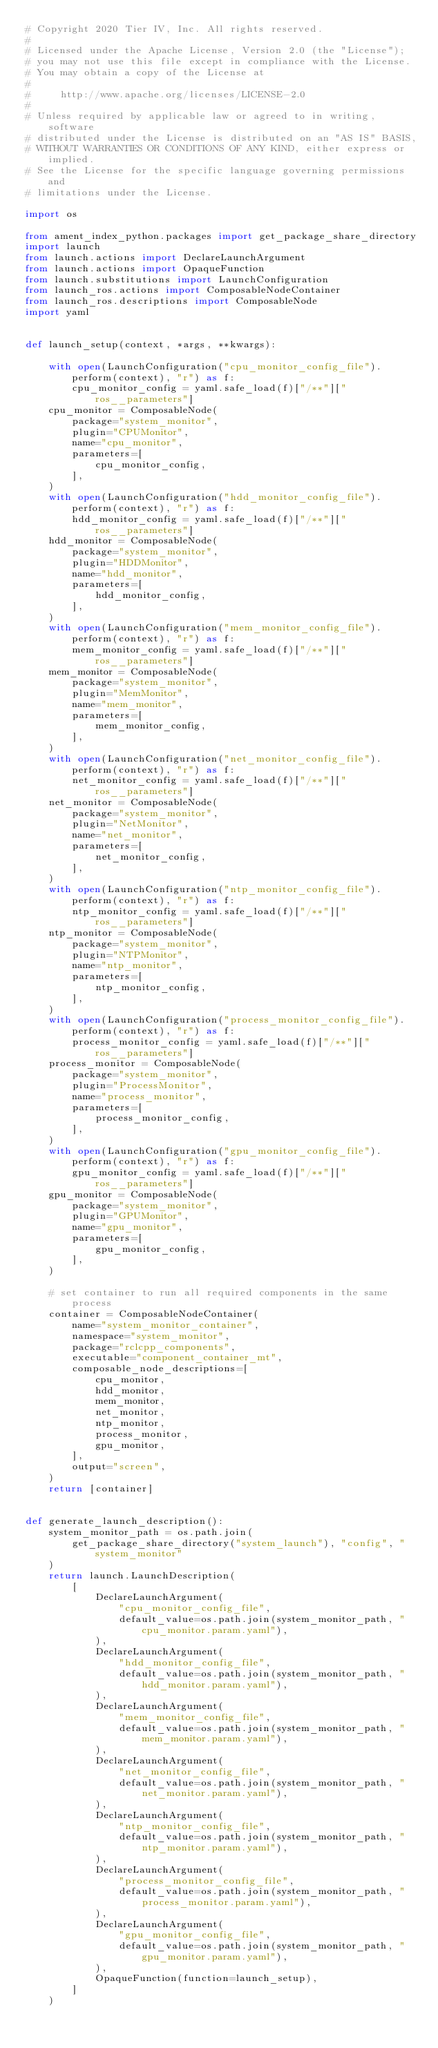Convert code to text. <code><loc_0><loc_0><loc_500><loc_500><_Python_># Copyright 2020 Tier IV, Inc. All rights reserved.
#
# Licensed under the Apache License, Version 2.0 (the "License");
# you may not use this file except in compliance with the License.
# You may obtain a copy of the License at
#
#     http://www.apache.org/licenses/LICENSE-2.0
#
# Unless required by applicable law or agreed to in writing, software
# distributed under the License is distributed on an "AS IS" BASIS,
# WITHOUT WARRANTIES OR CONDITIONS OF ANY KIND, either express or implied.
# See the License for the specific language governing permissions and
# limitations under the License.

import os

from ament_index_python.packages import get_package_share_directory
import launch
from launch.actions import DeclareLaunchArgument
from launch.actions import OpaqueFunction
from launch.substitutions import LaunchConfiguration
from launch_ros.actions import ComposableNodeContainer
from launch_ros.descriptions import ComposableNode
import yaml


def launch_setup(context, *args, **kwargs):

    with open(LaunchConfiguration("cpu_monitor_config_file").perform(context), "r") as f:
        cpu_monitor_config = yaml.safe_load(f)["/**"]["ros__parameters"]
    cpu_monitor = ComposableNode(
        package="system_monitor",
        plugin="CPUMonitor",
        name="cpu_monitor",
        parameters=[
            cpu_monitor_config,
        ],
    )
    with open(LaunchConfiguration("hdd_monitor_config_file").perform(context), "r") as f:
        hdd_monitor_config = yaml.safe_load(f)["/**"]["ros__parameters"]
    hdd_monitor = ComposableNode(
        package="system_monitor",
        plugin="HDDMonitor",
        name="hdd_monitor",
        parameters=[
            hdd_monitor_config,
        ],
    )
    with open(LaunchConfiguration("mem_monitor_config_file").perform(context), "r") as f:
        mem_monitor_config = yaml.safe_load(f)["/**"]["ros__parameters"]
    mem_monitor = ComposableNode(
        package="system_monitor",
        plugin="MemMonitor",
        name="mem_monitor",
        parameters=[
            mem_monitor_config,
        ],
    )
    with open(LaunchConfiguration("net_monitor_config_file").perform(context), "r") as f:
        net_monitor_config = yaml.safe_load(f)["/**"]["ros__parameters"]
    net_monitor = ComposableNode(
        package="system_monitor",
        plugin="NetMonitor",
        name="net_monitor",
        parameters=[
            net_monitor_config,
        ],
    )
    with open(LaunchConfiguration("ntp_monitor_config_file").perform(context), "r") as f:
        ntp_monitor_config = yaml.safe_load(f)["/**"]["ros__parameters"]
    ntp_monitor = ComposableNode(
        package="system_monitor",
        plugin="NTPMonitor",
        name="ntp_monitor",
        parameters=[
            ntp_monitor_config,
        ],
    )
    with open(LaunchConfiguration("process_monitor_config_file").perform(context), "r") as f:
        process_monitor_config = yaml.safe_load(f)["/**"]["ros__parameters"]
    process_monitor = ComposableNode(
        package="system_monitor",
        plugin="ProcessMonitor",
        name="process_monitor",
        parameters=[
            process_monitor_config,
        ],
    )
    with open(LaunchConfiguration("gpu_monitor_config_file").perform(context), "r") as f:
        gpu_monitor_config = yaml.safe_load(f)["/**"]["ros__parameters"]
    gpu_monitor = ComposableNode(
        package="system_monitor",
        plugin="GPUMonitor",
        name="gpu_monitor",
        parameters=[
            gpu_monitor_config,
        ],
    )

    # set container to run all required components in the same process
    container = ComposableNodeContainer(
        name="system_monitor_container",
        namespace="system_monitor",
        package="rclcpp_components",
        executable="component_container_mt",
        composable_node_descriptions=[
            cpu_monitor,
            hdd_monitor,
            mem_monitor,
            net_monitor,
            ntp_monitor,
            process_monitor,
            gpu_monitor,
        ],
        output="screen",
    )
    return [container]


def generate_launch_description():
    system_monitor_path = os.path.join(
        get_package_share_directory("system_launch"), "config", "system_monitor"
    )
    return launch.LaunchDescription(
        [
            DeclareLaunchArgument(
                "cpu_monitor_config_file",
                default_value=os.path.join(system_monitor_path, "cpu_monitor.param.yaml"),
            ),
            DeclareLaunchArgument(
                "hdd_monitor_config_file",
                default_value=os.path.join(system_monitor_path, "hdd_monitor.param.yaml"),
            ),
            DeclareLaunchArgument(
                "mem_monitor_config_file",
                default_value=os.path.join(system_monitor_path, "mem_monitor.param.yaml"),
            ),
            DeclareLaunchArgument(
                "net_monitor_config_file",
                default_value=os.path.join(system_monitor_path, "net_monitor.param.yaml"),
            ),
            DeclareLaunchArgument(
                "ntp_monitor_config_file",
                default_value=os.path.join(system_monitor_path, "ntp_monitor.param.yaml"),
            ),
            DeclareLaunchArgument(
                "process_monitor_config_file",
                default_value=os.path.join(system_monitor_path, "process_monitor.param.yaml"),
            ),
            DeclareLaunchArgument(
                "gpu_monitor_config_file",
                default_value=os.path.join(system_monitor_path, "gpu_monitor.param.yaml"),
            ),
            OpaqueFunction(function=launch_setup),
        ]
    )
</code> 